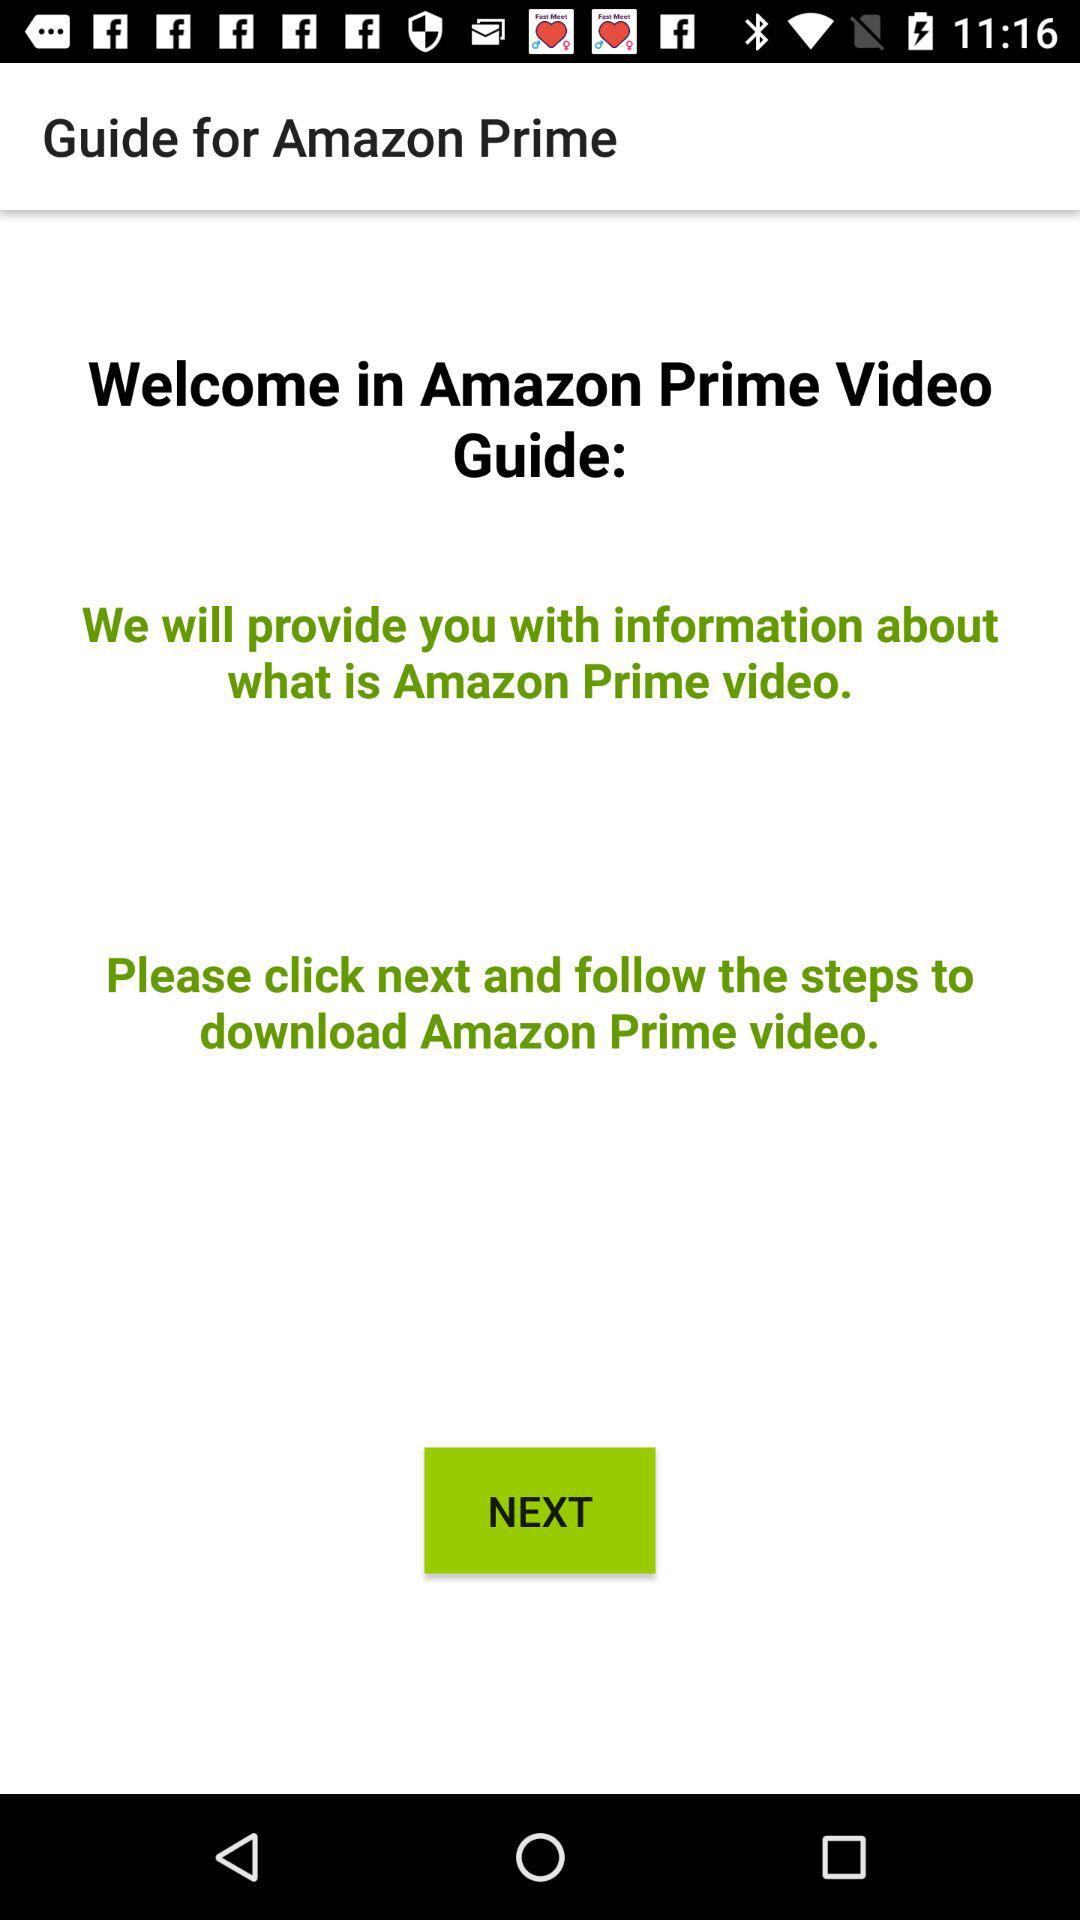What will the "Amazon Prime Video Guide" provide you? The "Amazon Prime Video Guide" provides you with information about what Amazon Prime Video is. 